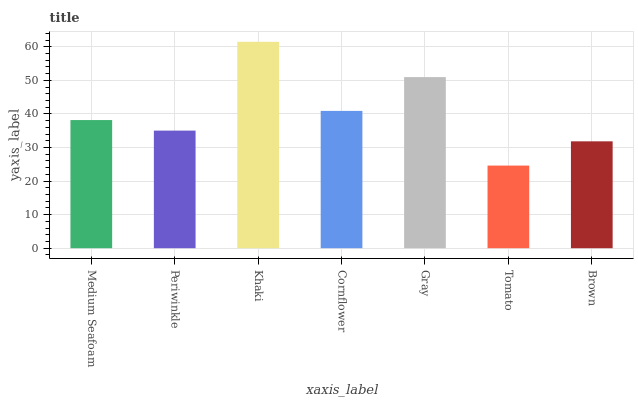Is Tomato the minimum?
Answer yes or no. Yes. Is Khaki the maximum?
Answer yes or no. Yes. Is Periwinkle the minimum?
Answer yes or no. No. Is Periwinkle the maximum?
Answer yes or no. No. Is Medium Seafoam greater than Periwinkle?
Answer yes or no. Yes. Is Periwinkle less than Medium Seafoam?
Answer yes or no. Yes. Is Periwinkle greater than Medium Seafoam?
Answer yes or no. No. Is Medium Seafoam less than Periwinkle?
Answer yes or no. No. Is Medium Seafoam the high median?
Answer yes or no. Yes. Is Medium Seafoam the low median?
Answer yes or no. Yes. Is Tomato the high median?
Answer yes or no. No. Is Brown the low median?
Answer yes or no. No. 